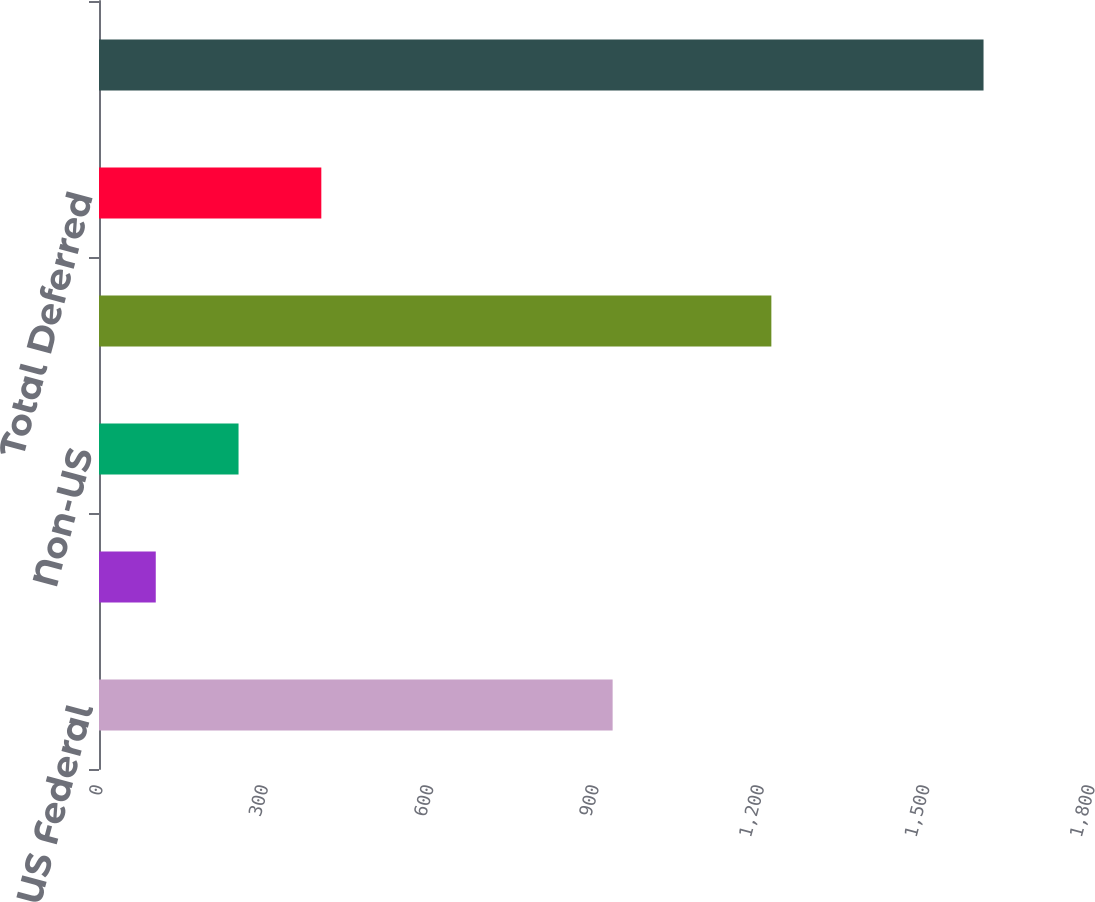<chart> <loc_0><loc_0><loc_500><loc_500><bar_chart><fcel>US Federal<fcel>US State and Local<fcel>Non-US<fcel>Total Current<fcel>Total Deferred<fcel>Total<nl><fcel>932<fcel>103<fcel>253.2<fcel>1220<fcel>403.4<fcel>1605<nl></chart> 